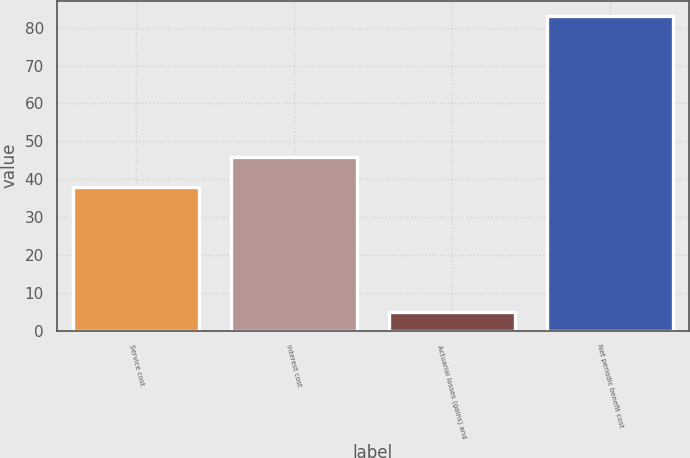Convert chart. <chart><loc_0><loc_0><loc_500><loc_500><bar_chart><fcel>Service cost<fcel>Interest cost<fcel>Actuarial losses (gains) and<fcel>Net periodic benefit cost<nl><fcel>38<fcel>45.8<fcel>5<fcel>83<nl></chart> 